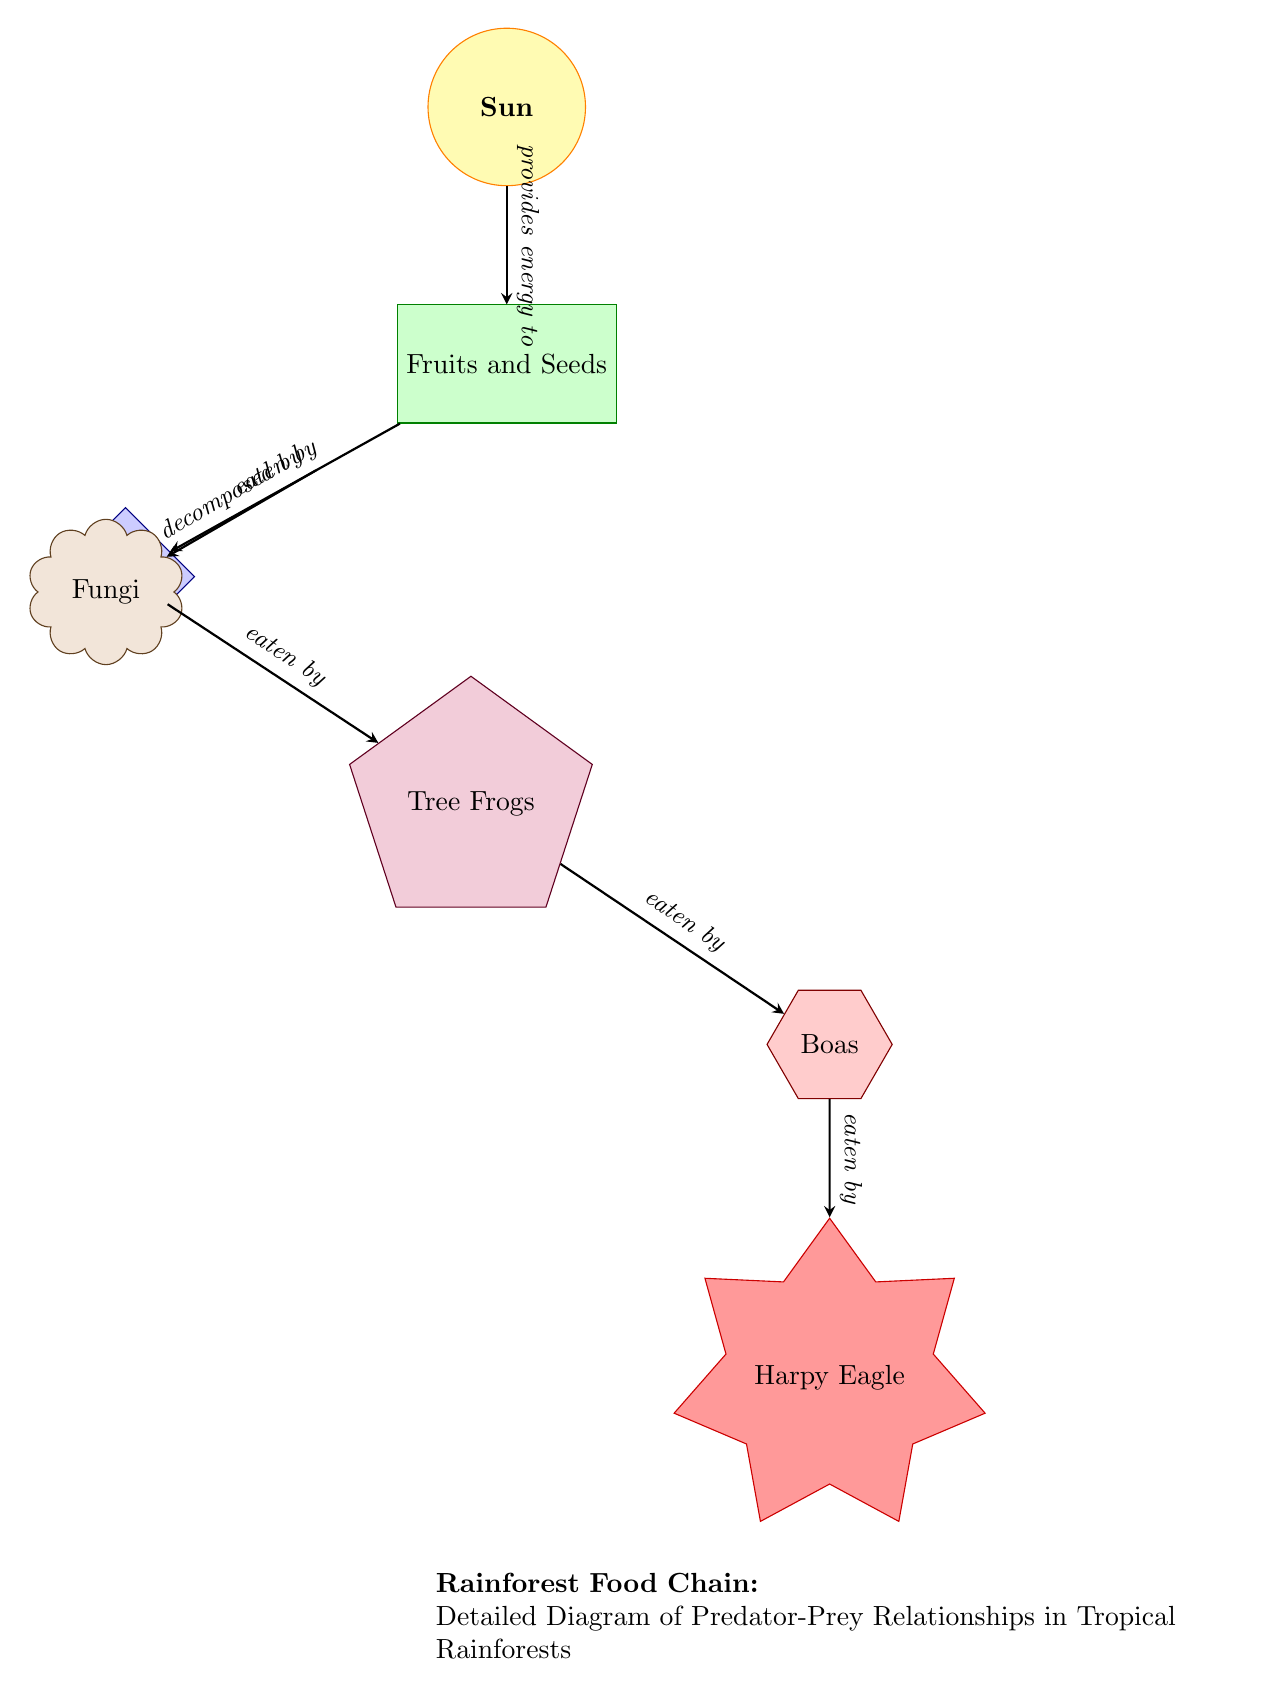What is the primary producer in this food chain? The diagram shows "Fruits and Seeds" as the first node below the sun, which is the source of energy. Primary producers are typically the first level of the food chain, which in this case is identified as producing energy via photosynthesis.
Answer: Fruits and Seeds Who is the apex predator in the diagram? The diagram indicates that "Harpy Eagle" is at the bottom of the food chain, consuming snakes, which are their prey. Apex predators are typically at the top of the food chain, and the Harpy Eagle is identified as such in this diagram.
Answer: Harpy Eagle How many primary consumers are represented? The diagram shows one primary consumer, "Insects," which is directly below the producer "Fruits and Seeds." A primary consumer feeds on producers, indicating that there is only one primary consumer node present in this food chain.
Answer: 1 What do fungi do in relation to fruits and seeds? The diagram illustrates that fungi are responsible for decomposing the "Fruits and Seeds," indicating that they break down organic matter to return nutrients to the ecosystem. Thus, the relationship shows fungi's role in nutrient cycling rather than being a direct consumer.
Answer: decomposed by Which consumer is directly eaten by snakes? In the diagram, "Tree Frogs" are shown as the secondary consumer that is eaten by the tertiary consumer, which is represented by "Boas" (snakes). The direct relationship indicates that Tree Frogs serve as prey for snakes.
Answer: Tree Frogs What type of relationship is depicted between insects and frogs? The diagram shows a direct arrow from "Insects" to "Tree Frogs," labeled as "eaten by," which indicates a predator-prey relationship where Tree Frogs are primary consumers feeding on insects.
Answer: eaten by How many nodes are involved in this food chain? The diagram includes seven nodes: Sun, Fruits and Seeds, Insects, Tree Frogs, Boas, Harpy Eagle, and Fungi. To find this, each distinct component of the food chain is counted, resulting in a total of seven.
Answer: 7 What is the role of the sun in this diagram? The sun is depicted as the energy source for the entire food chain, providing energy for the "Fruits and Seeds," which are the primary producers. The explanation of its role is understood through its position at the top and the arrow pointing towards the producers.
Answer: provides energy to 